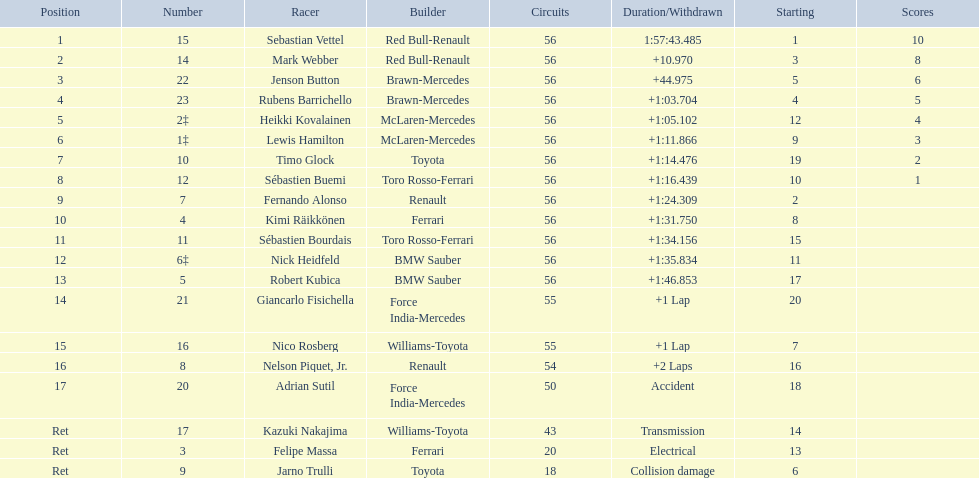Who are all of the drivers? Sebastian Vettel, Mark Webber, Jenson Button, Rubens Barrichello, Heikki Kovalainen, Lewis Hamilton, Timo Glock, Sébastien Buemi, Fernando Alonso, Kimi Räikkönen, Sébastien Bourdais, Nick Heidfeld, Robert Kubica, Giancarlo Fisichella, Nico Rosberg, Nelson Piquet, Jr., Adrian Sutil, Kazuki Nakajima, Felipe Massa, Jarno Trulli. Who were their constructors? Red Bull-Renault, Red Bull-Renault, Brawn-Mercedes, Brawn-Mercedes, McLaren-Mercedes, McLaren-Mercedes, Toyota, Toro Rosso-Ferrari, Renault, Ferrari, Toro Rosso-Ferrari, BMW Sauber, BMW Sauber, Force India-Mercedes, Williams-Toyota, Renault, Force India-Mercedes, Williams-Toyota, Ferrari, Toyota. Who was the first listed driver to not drive a ferrari?? Sebastian Vettel. 